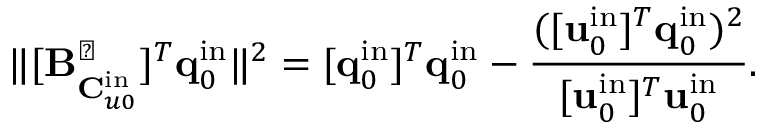Convert formula to latex. <formula><loc_0><loc_0><loc_500><loc_500>\| [ B _ { C _ { u 0 } ^ { i n } } ^ { \perp } ] ^ { T } q _ { 0 } ^ { i n } \| ^ { 2 } = [ q _ { 0 } ^ { i n } ] ^ { T } q _ { 0 } ^ { i n } - \frac { ( [ u _ { 0 } ^ { i n } ] ^ { T } q _ { 0 } ^ { i n } ) ^ { 2 } } { [ u _ { 0 } ^ { i n } ] ^ { T } u _ { 0 } ^ { i n } } .</formula> 